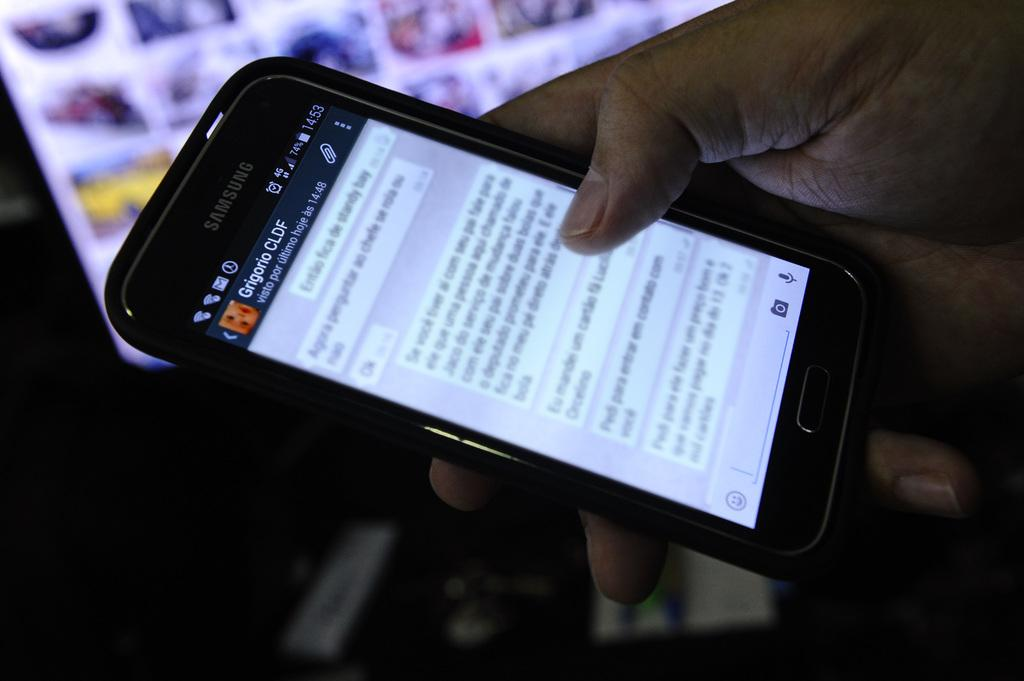<image>
Relay a brief, clear account of the picture shown. A person is holding a Samsung device with an article on the screen that is written in another language. 